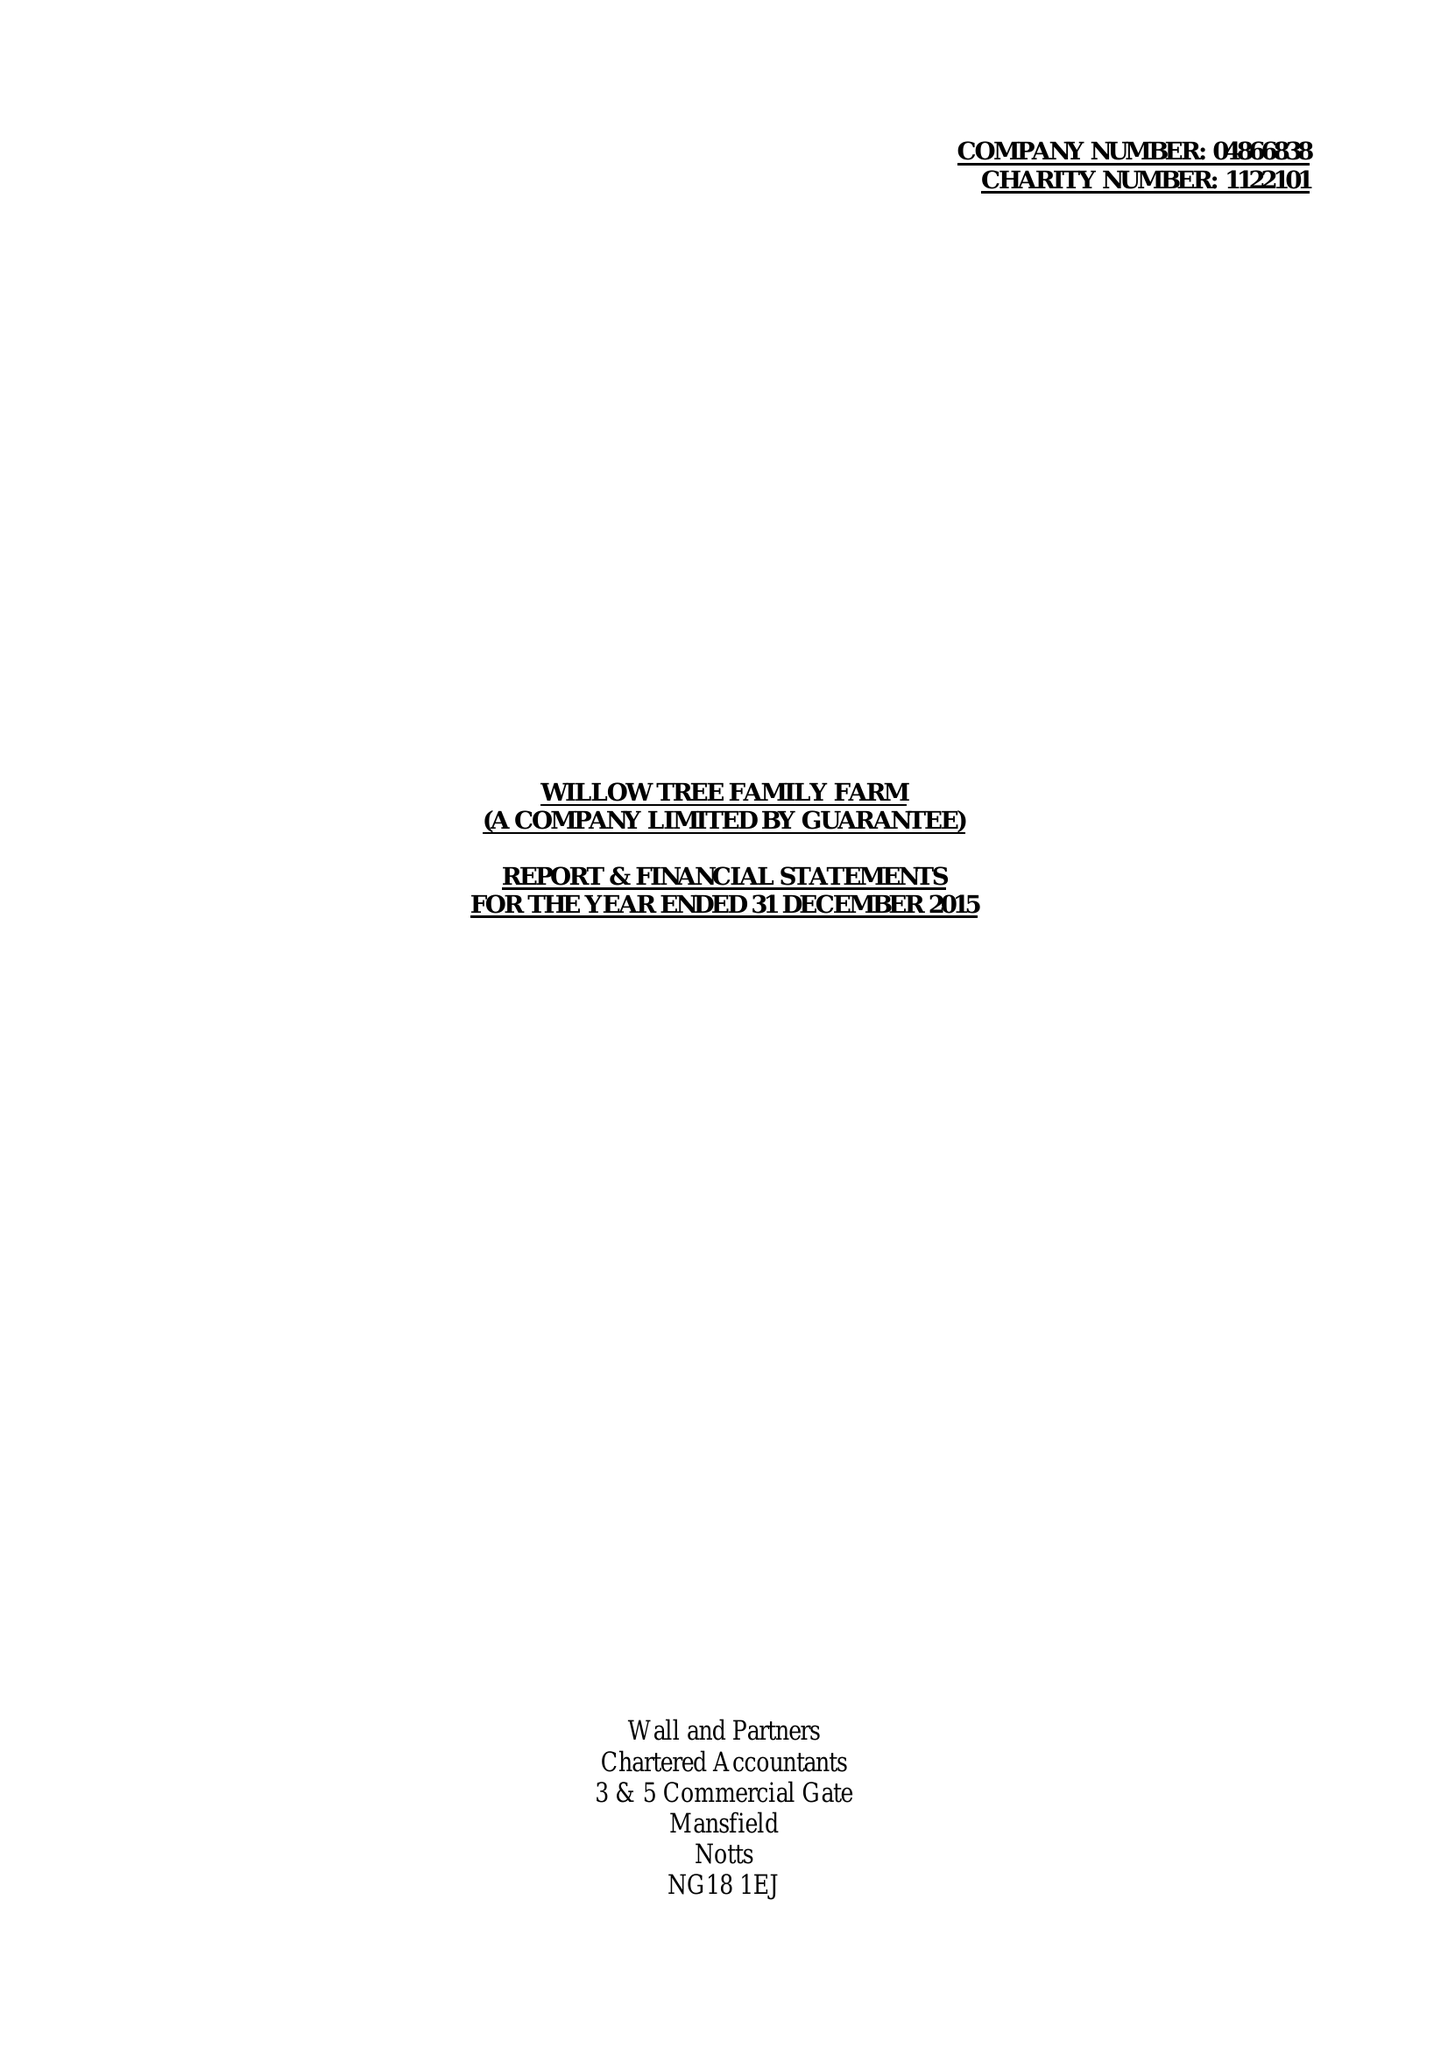What is the value for the income_annually_in_british_pounds?
Answer the question using a single word or phrase. 123033.00 